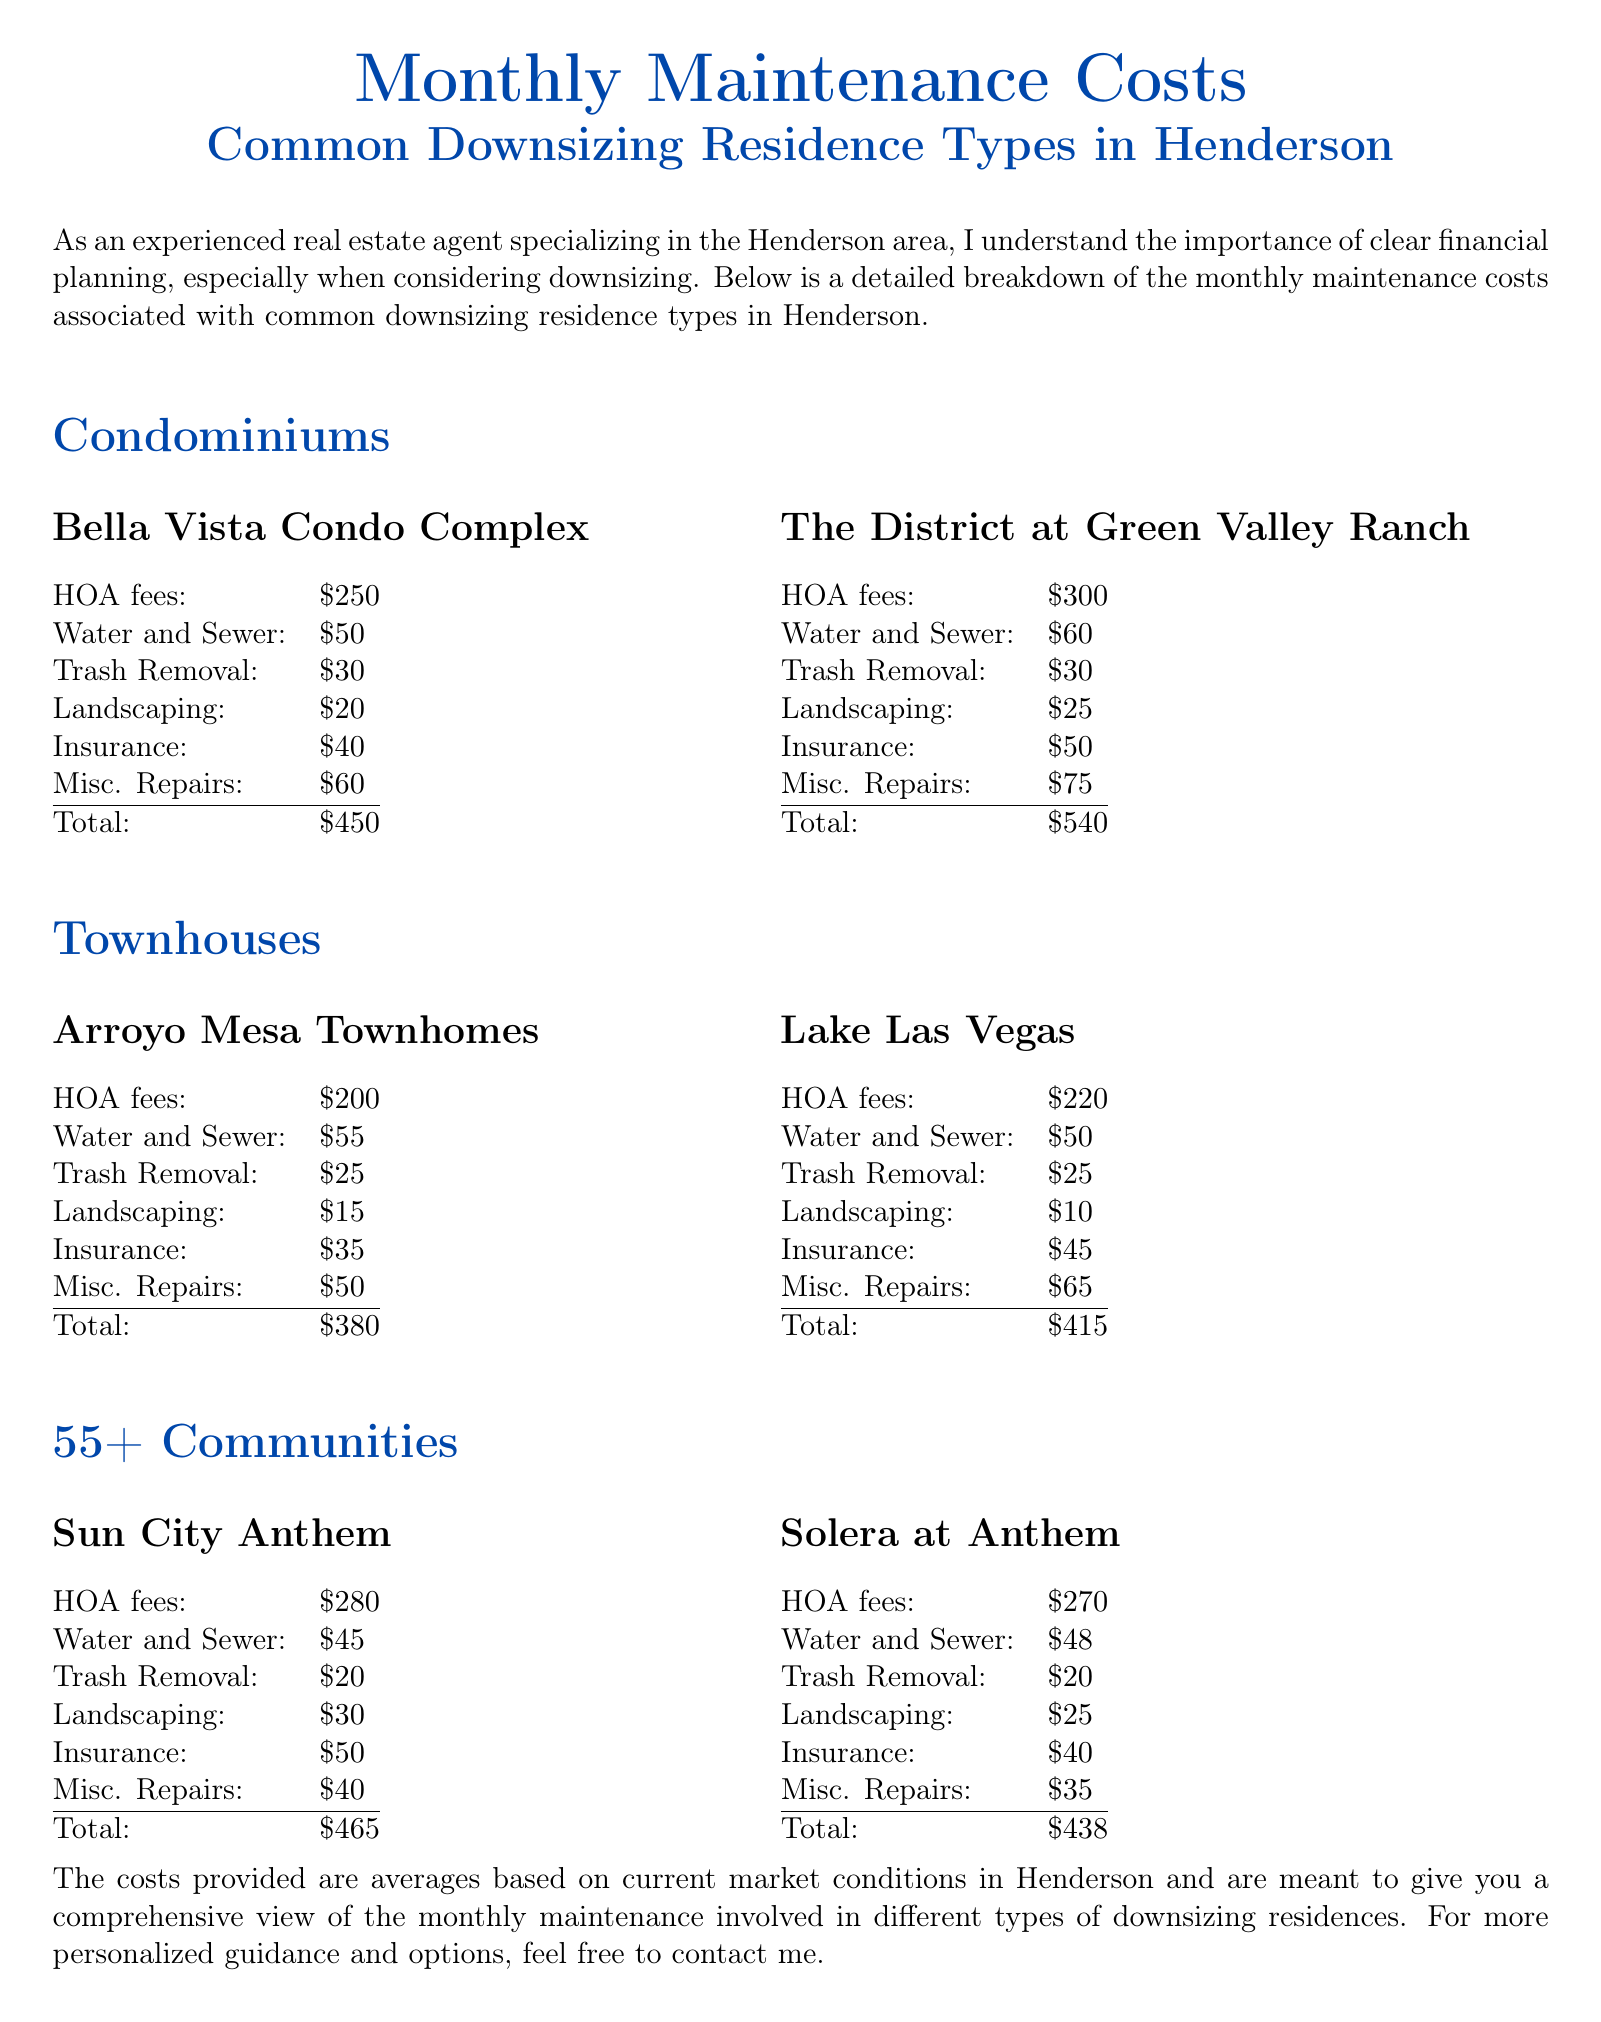What is the total monthly maintenance cost for Bella Vista Condo Complex? The total monthly maintenance cost for Bella Vista Condo Complex is obtained from the table under Condominiums, which states a total of $450.
Answer: $450 What are the insurance costs for Lake Las Vegas? The insurance costs for Lake Las Vegas are taken from the relevant table in the Townhouses section, which shows insurance costs of $45.
Answer: $45 Which property has the highest total maintenance cost? To find the property with the highest total maintenance cost, I compared all totals; The District at Green Valley Ranch has the highest total at $540.
Answer: $540 What is the total monthly maintenance cost for Solera at Anthem? The total monthly maintenance cost for Solera at Anthem can be found in the 55+ Communities section, where it is listed as $438.
Answer: $438 How much are the HOA fees for Arroyo Mesa Townhomes? The HOA fees for Arroyo Mesa Townhomes are listed in the Townhouses section at $200.
Answer: $200 What is the average total monthly maintenance cost for 55+ Communities? The average is derived from the totals of both properties in the 55+ Communities, which is ($465 + $438) / 2, resulting in $451.5.
Answer: $451.5 How much is the trash removal fee at The District at Green Valley Ranch? The trash removal fee for The District at Green Valley Ranch is stated in the Condominiums section as $30.
Answer: $30 What residence type does Sun City Anthem belong to? Sun City Anthem is categorized under the 55+ Communities section of the document.
Answer: 55+ Communities 